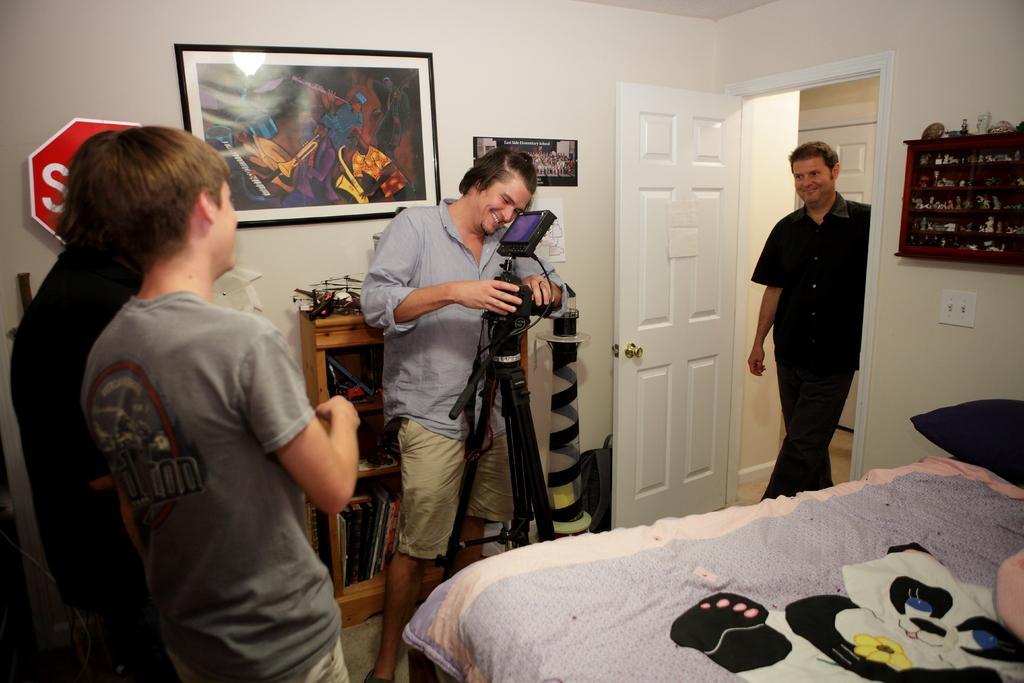Could you give a brief overview of what you see in this image? In this image I can see a group of people standing on the floor. I can also see there is a door and a photo on a wall. 